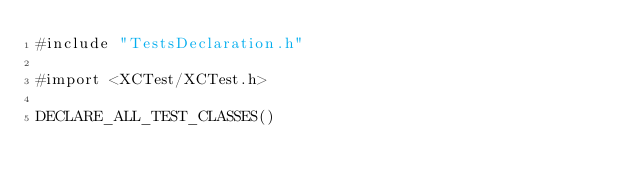<code> <loc_0><loc_0><loc_500><loc_500><_ObjectiveC_>#include "TestsDeclaration.h"

#import <XCTest/XCTest.h>

DECLARE_ALL_TEST_CLASSES()
</code> 